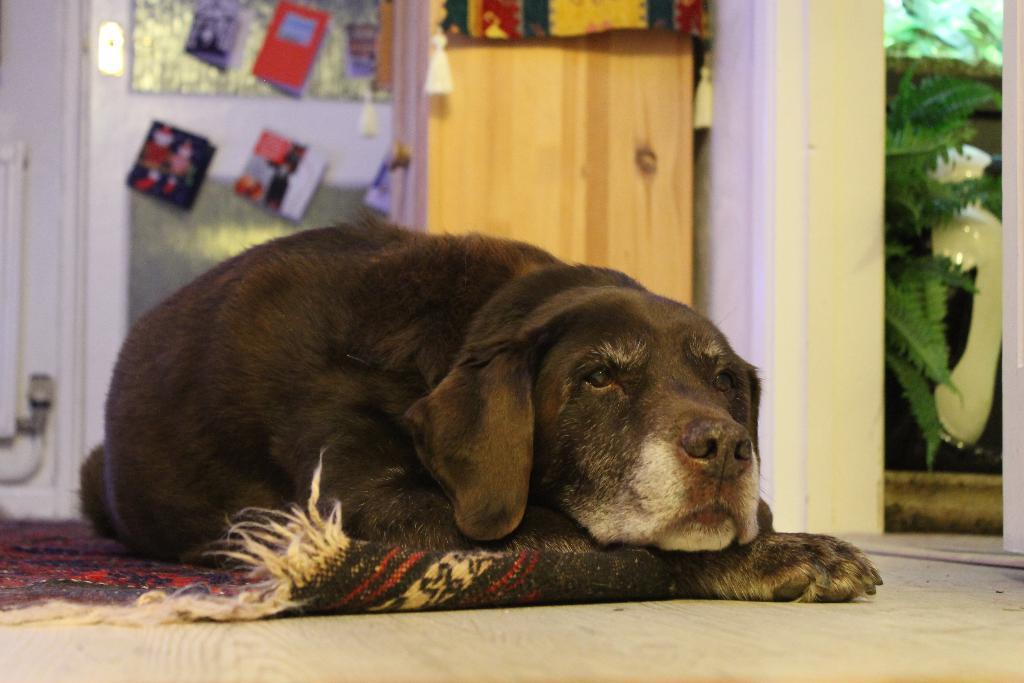Describe this image in one or two sentences. In this picture I can see a dog on the carpet and I can see plants and few greeting cards and looks like a wooden door and a cloth in the background. 